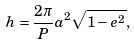Convert formula to latex. <formula><loc_0><loc_0><loc_500><loc_500>h = \frac { 2 \pi } { P } a ^ { 2 } \sqrt { 1 - e ^ { 2 } } ,</formula> 